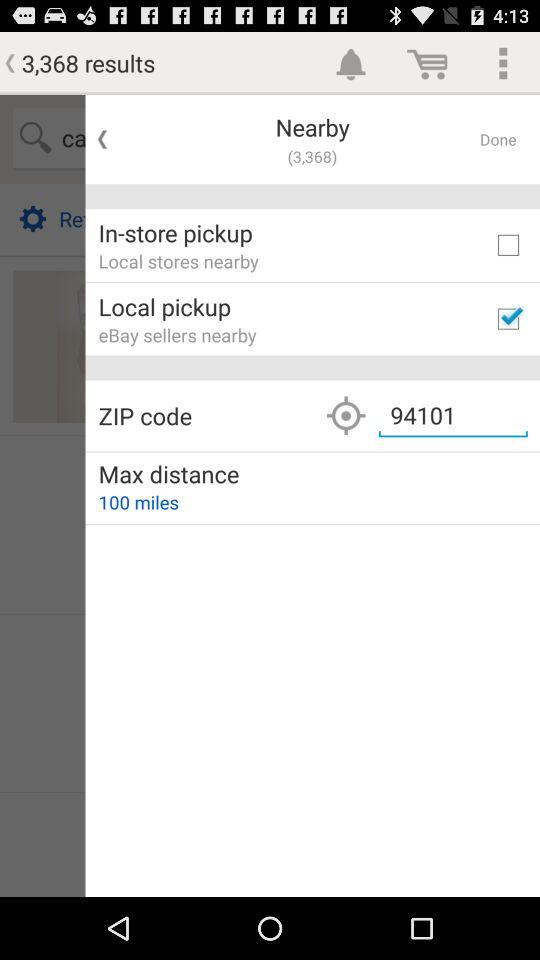How many results are showing? There are 3,368 results showing. 